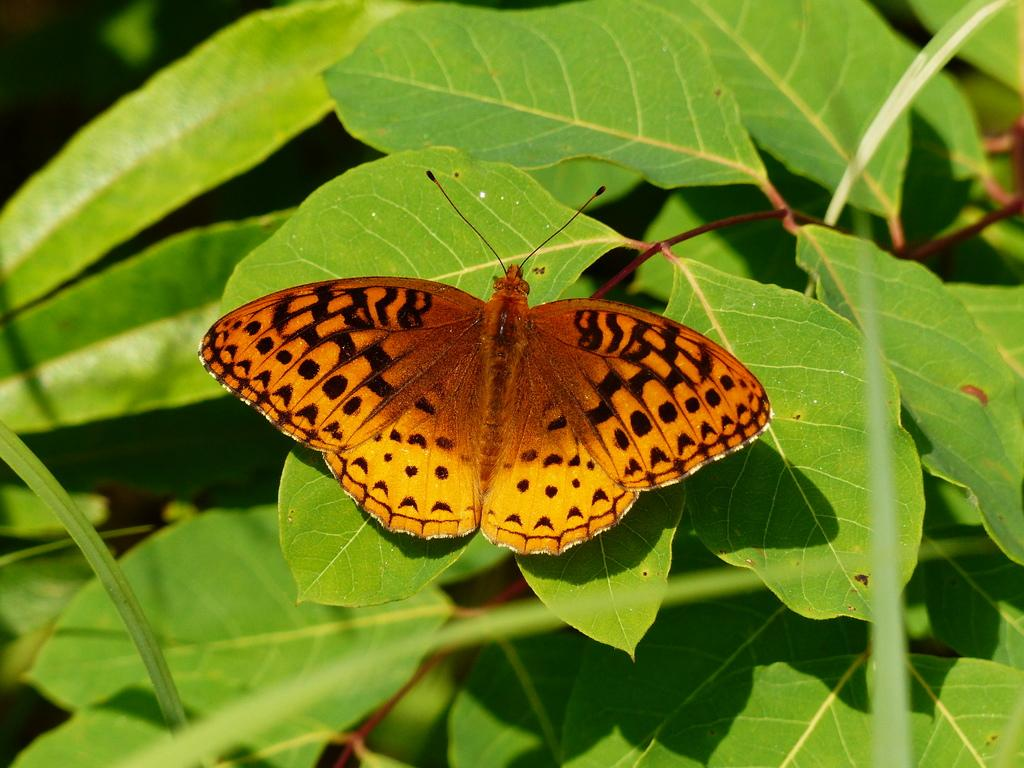What is the main subject of the image? There is a butterfly in the image. Where is the butterfly located? The butterfly is on leaves. What color is the arm of the butterfly in the image? There is no arm present on the butterfly, as butterflies have wings and not arms. 